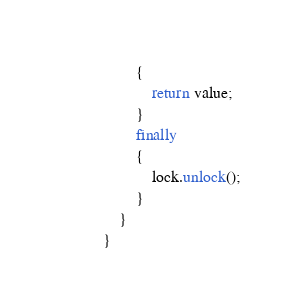Convert code to text. <code><loc_0><loc_0><loc_500><loc_500><_Java_>        {
            return value;
        }
        finally
        {
            lock.unlock();
        }
    }
}
</code> 